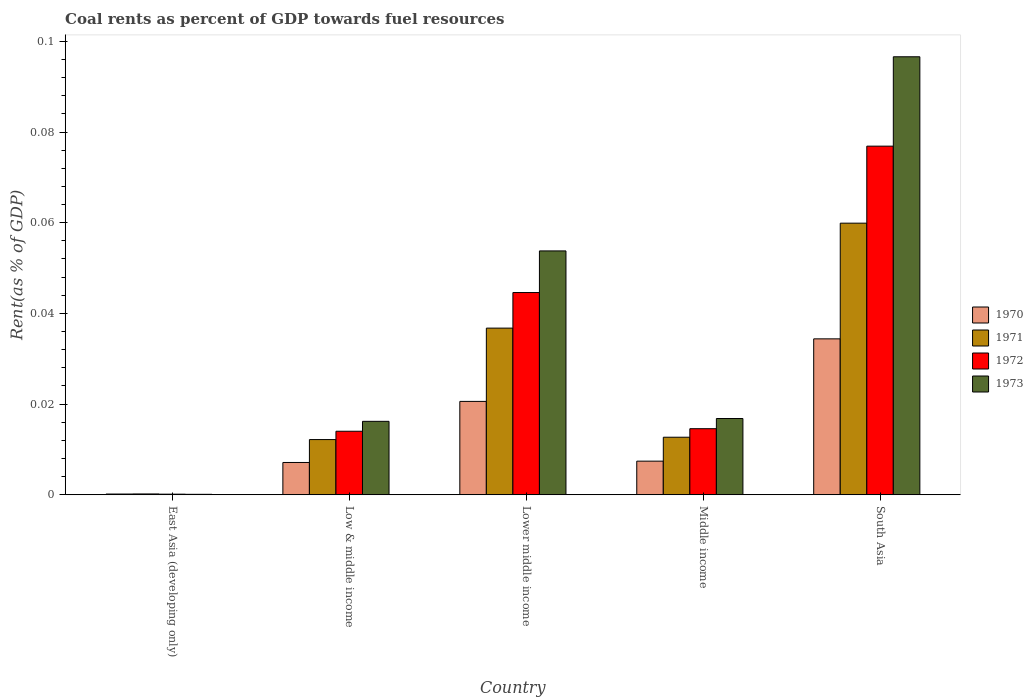Are the number of bars per tick equal to the number of legend labels?
Your answer should be very brief. Yes. How many bars are there on the 4th tick from the left?
Your answer should be compact. 4. How many bars are there on the 2nd tick from the right?
Your response must be concise. 4. What is the label of the 2nd group of bars from the left?
Your answer should be compact. Low & middle income. What is the coal rent in 1973 in East Asia (developing only)?
Your answer should be compact. 0. Across all countries, what is the maximum coal rent in 1970?
Keep it short and to the point. 0.03. Across all countries, what is the minimum coal rent in 1973?
Your answer should be compact. 0. In which country was the coal rent in 1973 maximum?
Offer a terse response. South Asia. In which country was the coal rent in 1971 minimum?
Keep it short and to the point. East Asia (developing only). What is the total coal rent in 1970 in the graph?
Your answer should be compact. 0.07. What is the difference between the coal rent in 1972 in Lower middle income and that in South Asia?
Provide a succinct answer. -0.03. What is the difference between the coal rent in 1972 in Low & middle income and the coal rent in 1971 in Middle income?
Provide a succinct answer. 0. What is the average coal rent in 1973 per country?
Give a very brief answer. 0.04. What is the difference between the coal rent of/in 1972 and coal rent of/in 1973 in South Asia?
Your response must be concise. -0.02. In how many countries, is the coal rent in 1970 greater than 0.04 %?
Provide a succinct answer. 0. What is the ratio of the coal rent in 1971 in East Asia (developing only) to that in Middle income?
Offer a terse response. 0.01. Is the coal rent in 1970 in East Asia (developing only) less than that in Lower middle income?
Your answer should be very brief. Yes. What is the difference between the highest and the second highest coal rent in 1973?
Make the answer very short. 0.08. What is the difference between the highest and the lowest coal rent in 1971?
Ensure brevity in your answer.  0.06. Is it the case that in every country, the sum of the coal rent in 1971 and coal rent in 1970 is greater than the sum of coal rent in 1973 and coal rent in 1972?
Your answer should be very brief. No. What does the 1st bar from the left in East Asia (developing only) represents?
Provide a succinct answer. 1970. Is it the case that in every country, the sum of the coal rent in 1973 and coal rent in 1970 is greater than the coal rent in 1971?
Your answer should be very brief. Yes. How many countries are there in the graph?
Offer a terse response. 5. Are the values on the major ticks of Y-axis written in scientific E-notation?
Provide a succinct answer. No. Does the graph contain any zero values?
Ensure brevity in your answer.  No. Does the graph contain grids?
Your response must be concise. No. Where does the legend appear in the graph?
Keep it short and to the point. Center right. What is the title of the graph?
Offer a terse response. Coal rents as percent of GDP towards fuel resources. What is the label or title of the X-axis?
Your answer should be very brief. Country. What is the label or title of the Y-axis?
Offer a terse response. Rent(as % of GDP). What is the Rent(as % of GDP) in 1970 in East Asia (developing only)?
Provide a succinct answer. 0. What is the Rent(as % of GDP) in 1971 in East Asia (developing only)?
Your answer should be compact. 0. What is the Rent(as % of GDP) in 1972 in East Asia (developing only)?
Make the answer very short. 0. What is the Rent(as % of GDP) in 1973 in East Asia (developing only)?
Keep it short and to the point. 0. What is the Rent(as % of GDP) of 1970 in Low & middle income?
Make the answer very short. 0.01. What is the Rent(as % of GDP) of 1971 in Low & middle income?
Your response must be concise. 0.01. What is the Rent(as % of GDP) in 1972 in Low & middle income?
Offer a terse response. 0.01. What is the Rent(as % of GDP) of 1973 in Low & middle income?
Provide a short and direct response. 0.02. What is the Rent(as % of GDP) in 1970 in Lower middle income?
Offer a terse response. 0.02. What is the Rent(as % of GDP) of 1971 in Lower middle income?
Your answer should be very brief. 0.04. What is the Rent(as % of GDP) in 1972 in Lower middle income?
Provide a succinct answer. 0.04. What is the Rent(as % of GDP) of 1973 in Lower middle income?
Keep it short and to the point. 0.05. What is the Rent(as % of GDP) in 1970 in Middle income?
Keep it short and to the point. 0.01. What is the Rent(as % of GDP) of 1971 in Middle income?
Provide a short and direct response. 0.01. What is the Rent(as % of GDP) in 1972 in Middle income?
Your answer should be compact. 0.01. What is the Rent(as % of GDP) in 1973 in Middle income?
Offer a terse response. 0.02. What is the Rent(as % of GDP) in 1970 in South Asia?
Give a very brief answer. 0.03. What is the Rent(as % of GDP) of 1971 in South Asia?
Provide a short and direct response. 0.06. What is the Rent(as % of GDP) in 1972 in South Asia?
Provide a succinct answer. 0.08. What is the Rent(as % of GDP) of 1973 in South Asia?
Make the answer very short. 0.1. Across all countries, what is the maximum Rent(as % of GDP) in 1970?
Offer a very short reply. 0.03. Across all countries, what is the maximum Rent(as % of GDP) of 1971?
Your answer should be compact. 0.06. Across all countries, what is the maximum Rent(as % of GDP) in 1972?
Your response must be concise. 0.08. Across all countries, what is the maximum Rent(as % of GDP) of 1973?
Provide a short and direct response. 0.1. Across all countries, what is the minimum Rent(as % of GDP) in 1970?
Offer a very short reply. 0. Across all countries, what is the minimum Rent(as % of GDP) of 1971?
Give a very brief answer. 0. Across all countries, what is the minimum Rent(as % of GDP) of 1972?
Provide a succinct answer. 0. Across all countries, what is the minimum Rent(as % of GDP) of 1973?
Your response must be concise. 0. What is the total Rent(as % of GDP) in 1970 in the graph?
Your answer should be compact. 0.07. What is the total Rent(as % of GDP) of 1971 in the graph?
Provide a succinct answer. 0.12. What is the total Rent(as % of GDP) in 1972 in the graph?
Provide a succinct answer. 0.15. What is the total Rent(as % of GDP) in 1973 in the graph?
Make the answer very short. 0.18. What is the difference between the Rent(as % of GDP) in 1970 in East Asia (developing only) and that in Low & middle income?
Give a very brief answer. -0.01. What is the difference between the Rent(as % of GDP) of 1971 in East Asia (developing only) and that in Low & middle income?
Provide a short and direct response. -0.01. What is the difference between the Rent(as % of GDP) in 1972 in East Asia (developing only) and that in Low & middle income?
Provide a succinct answer. -0.01. What is the difference between the Rent(as % of GDP) in 1973 in East Asia (developing only) and that in Low & middle income?
Offer a terse response. -0.02. What is the difference between the Rent(as % of GDP) of 1970 in East Asia (developing only) and that in Lower middle income?
Make the answer very short. -0.02. What is the difference between the Rent(as % of GDP) in 1971 in East Asia (developing only) and that in Lower middle income?
Keep it short and to the point. -0.04. What is the difference between the Rent(as % of GDP) in 1972 in East Asia (developing only) and that in Lower middle income?
Provide a succinct answer. -0.04. What is the difference between the Rent(as % of GDP) of 1973 in East Asia (developing only) and that in Lower middle income?
Your answer should be compact. -0.05. What is the difference between the Rent(as % of GDP) of 1970 in East Asia (developing only) and that in Middle income?
Provide a succinct answer. -0.01. What is the difference between the Rent(as % of GDP) of 1971 in East Asia (developing only) and that in Middle income?
Offer a terse response. -0.01. What is the difference between the Rent(as % of GDP) of 1972 in East Asia (developing only) and that in Middle income?
Provide a succinct answer. -0.01. What is the difference between the Rent(as % of GDP) of 1973 in East Asia (developing only) and that in Middle income?
Keep it short and to the point. -0.02. What is the difference between the Rent(as % of GDP) in 1970 in East Asia (developing only) and that in South Asia?
Your answer should be very brief. -0.03. What is the difference between the Rent(as % of GDP) of 1971 in East Asia (developing only) and that in South Asia?
Make the answer very short. -0.06. What is the difference between the Rent(as % of GDP) in 1972 in East Asia (developing only) and that in South Asia?
Your answer should be very brief. -0.08. What is the difference between the Rent(as % of GDP) in 1973 in East Asia (developing only) and that in South Asia?
Ensure brevity in your answer.  -0.1. What is the difference between the Rent(as % of GDP) in 1970 in Low & middle income and that in Lower middle income?
Offer a very short reply. -0.01. What is the difference between the Rent(as % of GDP) of 1971 in Low & middle income and that in Lower middle income?
Offer a terse response. -0.02. What is the difference between the Rent(as % of GDP) of 1972 in Low & middle income and that in Lower middle income?
Keep it short and to the point. -0.03. What is the difference between the Rent(as % of GDP) in 1973 in Low & middle income and that in Lower middle income?
Keep it short and to the point. -0.04. What is the difference between the Rent(as % of GDP) in 1970 in Low & middle income and that in Middle income?
Provide a succinct answer. -0. What is the difference between the Rent(as % of GDP) of 1971 in Low & middle income and that in Middle income?
Give a very brief answer. -0. What is the difference between the Rent(as % of GDP) in 1972 in Low & middle income and that in Middle income?
Keep it short and to the point. -0. What is the difference between the Rent(as % of GDP) in 1973 in Low & middle income and that in Middle income?
Your answer should be very brief. -0. What is the difference between the Rent(as % of GDP) of 1970 in Low & middle income and that in South Asia?
Keep it short and to the point. -0.03. What is the difference between the Rent(as % of GDP) in 1971 in Low & middle income and that in South Asia?
Provide a succinct answer. -0.05. What is the difference between the Rent(as % of GDP) in 1972 in Low & middle income and that in South Asia?
Make the answer very short. -0.06. What is the difference between the Rent(as % of GDP) of 1973 in Low & middle income and that in South Asia?
Provide a short and direct response. -0.08. What is the difference between the Rent(as % of GDP) in 1970 in Lower middle income and that in Middle income?
Keep it short and to the point. 0.01. What is the difference between the Rent(as % of GDP) in 1971 in Lower middle income and that in Middle income?
Provide a succinct answer. 0.02. What is the difference between the Rent(as % of GDP) of 1972 in Lower middle income and that in Middle income?
Keep it short and to the point. 0.03. What is the difference between the Rent(as % of GDP) of 1973 in Lower middle income and that in Middle income?
Your answer should be compact. 0.04. What is the difference between the Rent(as % of GDP) of 1970 in Lower middle income and that in South Asia?
Ensure brevity in your answer.  -0.01. What is the difference between the Rent(as % of GDP) of 1971 in Lower middle income and that in South Asia?
Your answer should be compact. -0.02. What is the difference between the Rent(as % of GDP) in 1972 in Lower middle income and that in South Asia?
Provide a succinct answer. -0.03. What is the difference between the Rent(as % of GDP) of 1973 in Lower middle income and that in South Asia?
Ensure brevity in your answer.  -0.04. What is the difference between the Rent(as % of GDP) of 1970 in Middle income and that in South Asia?
Your answer should be very brief. -0.03. What is the difference between the Rent(as % of GDP) of 1971 in Middle income and that in South Asia?
Ensure brevity in your answer.  -0.05. What is the difference between the Rent(as % of GDP) in 1972 in Middle income and that in South Asia?
Ensure brevity in your answer.  -0.06. What is the difference between the Rent(as % of GDP) in 1973 in Middle income and that in South Asia?
Your answer should be very brief. -0.08. What is the difference between the Rent(as % of GDP) in 1970 in East Asia (developing only) and the Rent(as % of GDP) in 1971 in Low & middle income?
Your answer should be compact. -0.01. What is the difference between the Rent(as % of GDP) in 1970 in East Asia (developing only) and the Rent(as % of GDP) in 1972 in Low & middle income?
Your answer should be very brief. -0.01. What is the difference between the Rent(as % of GDP) of 1970 in East Asia (developing only) and the Rent(as % of GDP) of 1973 in Low & middle income?
Your answer should be very brief. -0.02. What is the difference between the Rent(as % of GDP) in 1971 in East Asia (developing only) and the Rent(as % of GDP) in 1972 in Low & middle income?
Your answer should be compact. -0.01. What is the difference between the Rent(as % of GDP) in 1971 in East Asia (developing only) and the Rent(as % of GDP) in 1973 in Low & middle income?
Offer a very short reply. -0.02. What is the difference between the Rent(as % of GDP) in 1972 in East Asia (developing only) and the Rent(as % of GDP) in 1973 in Low & middle income?
Your answer should be very brief. -0.02. What is the difference between the Rent(as % of GDP) of 1970 in East Asia (developing only) and the Rent(as % of GDP) of 1971 in Lower middle income?
Your answer should be compact. -0.04. What is the difference between the Rent(as % of GDP) of 1970 in East Asia (developing only) and the Rent(as % of GDP) of 1972 in Lower middle income?
Your answer should be very brief. -0.04. What is the difference between the Rent(as % of GDP) of 1970 in East Asia (developing only) and the Rent(as % of GDP) of 1973 in Lower middle income?
Offer a terse response. -0.05. What is the difference between the Rent(as % of GDP) in 1971 in East Asia (developing only) and the Rent(as % of GDP) in 1972 in Lower middle income?
Provide a succinct answer. -0.04. What is the difference between the Rent(as % of GDP) in 1971 in East Asia (developing only) and the Rent(as % of GDP) in 1973 in Lower middle income?
Offer a very short reply. -0.05. What is the difference between the Rent(as % of GDP) in 1972 in East Asia (developing only) and the Rent(as % of GDP) in 1973 in Lower middle income?
Your answer should be compact. -0.05. What is the difference between the Rent(as % of GDP) in 1970 in East Asia (developing only) and the Rent(as % of GDP) in 1971 in Middle income?
Your answer should be very brief. -0.01. What is the difference between the Rent(as % of GDP) of 1970 in East Asia (developing only) and the Rent(as % of GDP) of 1972 in Middle income?
Offer a very short reply. -0.01. What is the difference between the Rent(as % of GDP) of 1970 in East Asia (developing only) and the Rent(as % of GDP) of 1973 in Middle income?
Your answer should be very brief. -0.02. What is the difference between the Rent(as % of GDP) in 1971 in East Asia (developing only) and the Rent(as % of GDP) in 1972 in Middle income?
Provide a succinct answer. -0.01. What is the difference between the Rent(as % of GDP) in 1971 in East Asia (developing only) and the Rent(as % of GDP) in 1973 in Middle income?
Give a very brief answer. -0.02. What is the difference between the Rent(as % of GDP) in 1972 in East Asia (developing only) and the Rent(as % of GDP) in 1973 in Middle income?
Provide a short and direct response. -0.02. What is the difference between the Rent(as % of GDP) of 1970 in East Asia (developing only) and the Rent(as % of GDP) of 1971 in South Asia?
Provide a short and direct response. -0.06. What is the difference between the Rent(as % of GDP) in 1970 in East Asia (developing only) and the Rent(as % of GDP) in 1972 in South Asia?
Ensure brevity in your answer.  -0.08. What is the difference between the Rent(as % of GDP) of 1970 in East Asia (developing only) and the Rent(as % of GDP) of 1973 in South Asia?
Give a very brief answer. -0.1. What is the difference between the Rent(as % of GDP) of 1971 in East Asia (developing only) and the Rent(as % of GDP) of 1972 in South Asia?
Your answer should be compact. -0.08. What is the difference between the Rent(as % of GDP) of 1971 in East Asia (developing only) and the Rent(as % of GDP) of 1973 in South Asia?
Offer a very short reply. -0.1. What is the difference between the Rent(as % of GDP) of 1972 in East Asia (developing only) and the Rent(as % of GDP) of 1973 in South Asia?
Your answer should be very brief. -0.1. What is the difference between the Rent(as % of GDP) in 1970 in Low & middle income and the Rent(as % of GDP) in 1971 in Lower middle income?
Make the answer very short. -0.03. What is the difference between the Rent(as % of GDP) in 1970 in Low & middle income and the Rent(as % of GDP) in 1972 in Lower middle income?
Provide a short and direct response. -0.04. What is the difference between the Rent(as % of GDP) of 1970 in Low & middle income and the Rent(as % of GDP) of 1973 in Lower middle income?
Provide a succinct answer. -0.05. What is the difference between the Rent(as % of GDP) of 1971 in Low & middle income and the Rent(as % of GDP) of 1972 in Lower middle income?
Give a very brief answer. -0.03. What is the difference between the Rent(as % of GDP) of 1971 in Low & middle income and the Rent(as % of GDP) of 1973 in Lower middle income?
Provide a short and direct response. -0.04. What is the difference between the Rent(as % of GDP) of 1972 in Low & middle income and the Rent(as % of GDP) of 1973 in Lower middle income?
Ensure brevity in your answer.  -0.04. What is the difference between the Rent(as % of GDP) in 1970 in Low & middle income and the Rent(as % of GDP) in 1971 in Middle income?
Keep it short and to the point. -0.01. What is the difference between the Rent(as % of GDP) of 1970 in Low & middle income and the Rent(as % of GDP) of 1972 in Middle income?
Ensure brevity in your answer.  -0.01. What is the difference between the Rent(as % of GDP) of 1970 in Low & middle income and the Rent(as % of GDP) of 1973 in Middle income?
Keep it short and to the point. -0.01. What is the difference between the Rent(as % of GDP) of 1971 in Low & middle income and the Rent(as % of GDP) of 1972 in Middle income?
Provide a short and direct response. -0. What is the difference between the Rent(as % of GDP) of 1971 in Low & middle income and the Rent(as % of GDP) of 1973 in Middle income?
Provide a succinct answer. -0. What is the difference between the Rent(as % of GDP) in 1972 in Low & middle income and the Rent(as % of GDP) in 1973 in Middle income?
Make the answer very short. -0. What is the difference between the Rent(as % of GDP) in 1970 in Low & middle income and the Rent(as % of GDP) in 1971 in South Asia?
Offer a very short reply. -0.05. What is the difference between the Rent(as % of GDP) of 1970 in Low & middle income and the Rent(as % of GDP) of 1972 in South Asia?
Your response must be concise. -0.07. What is the difference between the Rent(as % of GDP) of 1970 in Low & middle income and the Rent(as % of GDP) of 1973 in South Asia?
Your answer should be compact. -0.09. What is the difference between the Rent(as % of GDP) in 1971 in Low & middle income and the Rent(as % of GDP) in 1972 in South Asia?
Your answer should be very brief. -0.06. What is the difference between the Rent(as % of GDP) in 1971 in Low & middle income and the Rent(as % of GDP) in 1973 in South Asia?
Keep it short and to the point. -0.08. What is the difference between the Rent(as % of GDP) in 1972 in Low & middle income and the Rent(as % of GDP) in 1973 in South Asia?
Your answer should be compact. -0.08. What is the difference between the Rent(as % of GDP) of 1970 in Lower middle income and the Rent(as % of GDP) of 1971 in Middle income?
Your response must be concise. 0.01. What is the difference between the Rent(as % of GDP) in 1970 in Lower middle income and the Rent(as % of GDP) in 1972 in Middle income?
Offer a very short reply. 0.01. What is the difference between the Rent(as % of GDP) of 1970 in Lower middle income and the Rent(as % of GDP) of 1973 in Middle income?
Provide a short and direct response. 0. What is the difference between the Rent(as % of GDP) of 1971 in Lower middle income and the Rent(as % of GDP) of 1972 in Middle income?
Keep it short and to the point. 0.02. What is the difference between the Rent(as % of GDP) in 1971 in Lower middle income and the Rent(as % of GDP) in 1973 in Middle income?
Give a very brief answer. 0.02. What is the difference between the Rent(as % of GDP) of 1972 in Lower middle income and the Rent(as % of GDP) of 1973 in Middle income?
Your answer should be very brief. 0.03. What is the difference between the Rent(as % of GDP) in 1970 in Lower middle income and the Rent(as % of GDP) in 1971 in South Asia?
Offer a very short reply. -0.04. What is the difference between the Rent(as % of GDP) of 1970 in Lower middle income and the Rent(as % of GDP) of 1972 in South Asia?
Your answer should be compact. -0.06. What is the difference between the Rent(as % of GDP) of 1970 in Lower middle income and the Rent(as % of GDP) of 1973 in South Asia?
Ensure brevity in your answer.  -0.08. What is the difference between the Rent(as % of GDP) in 1971 in Lower middle income and the Rent(as % of GDP) in 1972 in South Asia?
Give a very brief answer. -0.04. What is the difference between the Rent(as % of GDP) in 1971 in Lower middle income and the Rent(as % of GDP) in 1973 in South Asia?
Your answer should be compact. -0.06. What is the difference between the Rent(as % of GDP) of 1972 in Lower middle income and the Rent(as % of GDP) of 1973 in South Asia?
Ensure brevity in your answer.  -0.05. What is the difference between the Rent(as % of GDP) in 1970 in Middle income and the Rent(as % of GDP) in 1971 in South Asia?
Provide a short and direct response. -0.05. What is the difference between the Rent(as % of GDP) in 1970 in Middle income and the Rent(as % of GDP) in 1972 in South Asia?
Give a very brief answer. -0.07. What is the difference between the Rent(as % of GDP) in 1970 in Middle income and the Rent(as % of GDP) in 1973 in South Asia?
Make the answer very short. -0.09. What is the difference between the Rent(as % of GDP) of 1971 in Middle income and the Rent(as % of GDP) of 1972 in South Asia?
Ensure brevity in your answer.  -0.06. What is the difference between the Rent(as % of GDP) in 1971 in Middle income and the Rent(as % of GDP) in 1973 in South Asia?
Provide a short and direct response. -0.08. What is the difference between the Rent(as % of GDP) of 1972 in Middle income and the Rent(as % of GDP) of 1973 in South Asia?
Ensure brevity in your answer.  -0.08. What is the average Rent(as % of GDP) in 1970 per country?
Your response must be concise. 0.01. What is the average Rent(as % of GDP) of 1971 per country?
Give a very brief answer. 0.02. What is the average Rent(as % of GDP) of 1972 per country?
Ensure brevity in your answer.  0.03. What is the average Rent(as % of GDP) in 1973 per country?
Provide a short and direct response. 0.04. What is the difference between the Rent(as % of GDP) of 1970 and Rent(as % of GDP) of 1971 in East Asia (developing only)?
Your answer should be very brief. -0. What is the difference between the Rent(as % of GDP) in 1970 and Rent(as % of GDP) in 1973 in East Asia (developing only)?
Provide a short and direct response. 0. What is the difference between the Rent(as % of GDP) of 1971 and Rent(as % of GDP) of 1972 in East Asia (developing only)?
Provide a short and direct response. 0. What is the difference between the Rent(as % of GDP) in 1972 and Rent(as % of GDP) in 1973 in East Asia (developing only)?
Offer a terse response. 0. What is the difference between the Rent(as % of GDP) of 1970 and Rent(as % of GDP) of 1971 in Low & middle income?
Ensure brevity in your answer.  -0.01. What is the difference between the Rent(as % of GDP) in 1970 and Rent(as % of GDP) in 1972 in Low & middle income?
Offer a very short reply. -0.01. What is the difference between the Rent(as % of GDP) in 1970 and Rent(as % of GDP) in 1973 in Low & middle income?
Ensure brevity in your answer.  -0.01. What is the difference between the Rent(as % of GDP) in 1971 and Rent(as % of GDP) in 1972 in Low & middle income?
Ensure brevity in your answer.  -0. What is the difference between the Rent(as % of GDP) of 1971 and Rent(as % of GDP) of 1973 in Low & middle income?
Your response must be concise. -0. What is the difference between the Rent(as % of GDP) in 1972 and Rent(as % of GDP) in 1973 in Low & middle income?
Provide a succinct answer. -0. What is the difference between the Rent(as % of GDP) of 1970 and Rent(as % of GDP) of 1971 in Lower middle income?
Make the answer very short. -0.02. What is the difference between the Rent(as % of GDP) of 1970 and Rent(as % of GDP) of 1972 in Lower middle income?
Your answer should be very brief. -0.02. What is the difference between the Rent(as % of GDP) of 1970 and Rent(as % of GDP) of 1973 in Lower middle income?
Ensure brevity in your answer.  -0.03. What is the difference between the Rent(as % of GDP) of 1971 and Rent(as % of GDP) of 1972 in Lower middle income?
Provide a short and direct response. -0.01. What is the difference between the Rent(as % of GDP) of 1971 and Rent(as % of GDP) of 1973 in Lower middle income?
Give a very brief answer. -0.02. What is the difference between the Rent(as % of GDP) in 1972 and Rent(as % of GDP) in 1973 in Lower middle income?
Give a very brief answer. -0.01. What is the difference between the Rent(as % of GDP) in 1970 and Rent(as % of GDP) in 1971 in Middle income?
Offer a terse response. -0.01. What is the difference between the Rent(as % of GDP) in 1970 and Rent(as % of GDP) in 1972 in Middle income?
Keep it short and to the point. -0.01. What is the difference between the Rent(as % of GDP) in 1970 and Rent(as % of GDP) in 1973 in Middle income?
Give a very brief answer. -0.01. What is the difference between the Rent(as % of GDP) in 1971 and Rent(as % of GDP) in 1972 in Middle income?
Provide a succinct answer. -0. What is the difference between the Rent(as % of GDP) of 1971 and Rent(as % of GDP) of 1973 in Middle income?
Keep it short and to the point. -0. What is the difference between the Rent(as % of GDP) of 1972 and Rent(as % of GDP) of 1973 in Middle income?
Make the answer very short. -0. What is the difference between the Rent(as % of GDP) in 1970 and Rent(as % of GDP) in 1971 in South Asia?
Provide a succinct answer. -0.03. What is the difference between the Rent(as % of GDP) in 1970 and Rent(as % of GDP) in 1972 in South Asia?
Provide a succinct answer. -0.04. What is the difference between the Rent(as % of GDP) of 1970 and Rent(as % of GDP) of 1973 in South Asia?
Offer a very short reply. -0.06. What is the difference between the Rent(as % of GDP) of 1971 and Rent(as % of GDP) of 1972 in South Asia?
Your answer should be compact. -0.02. What is the difference between the Rent(as % of GDP) in 1971 and Rent(as % of GDP) in 1973 in South Asia?
Provide a short and direct response. -0.04. What is the difference between the Rent(as % of GDP) in 1972 and Rent(as % of GDP) in 1973 in South Asia?
Provide a succinct answer. -0.02. What is the ratio of the Rent(as % of GDP) in 1970 in East Asia (developing only) to that in Low & middle income?
Make the answer very short. 0.02. What is the ratio of the Rent(as % of GDP) of 1971 in East Asia (developing only) to that in Low & middle income?
Your response must be concise. 0.02. What is the ratio of the Rent(as % of GDP) in 1972 in East Asia (developing only) to that in Low & middle income?
Your response must be concise. 0.01. What is the ratio of the Rent(as % of GDP) of 1973 in East Asia (developing only) to that in Low & middle income?
Keep it short and to the point. 0.01. What is the ratio of the Rent(as % of GDP) of 1970 in East Asia (developing only) to that in Lower middle income?
Your response must be concise. 0.01. What is the ratio of the Rent(as % of GDP) of 1971 in East Asia (developing only) to that in Lower middle income?
Make the answer very short. 0.01. What is the ratio of the Rent(as % of GDP) of 1972 in East Asia (developing only) to that in Lower middle income?
Provide a succinct answer. 0. What is the ratio of the Rent(as % of GDP) of 1973 in East Asia (developing only) to that in Lower middle income?
Give a very brief answer. 0. What is the ratio of the Rent(as % of GDP) of 1970 in East Asia (developing only) to that in Middle income?
Offer a terse response. 0.02. What is the ratio of the Rent(as % of GDP) in 1971 in East Asia (developing only) to that in Middle income?
Your response must be concise. 0.01. What is the ratio of the Rent(as % of GDP) of 1972 in East Asia (developing only) to that in Middle income?
Your answer should be compact. 0.01. What is the ratio of the Rent(as % of GDP) in 1973 in East Asia (developing only) to that in Middle income?
Make the answer very short. 0.01. What is the ratio of the Rent(as % of GDP) of 1970 in East Asia (developing only) to that in South Asia?
Make the answer very short. 0. What is the ratio of the Rent(as % of GDP) in 1971 in East Asia (developing only) to that in South Asia?
Keep it short and to the point. 0. What is the ratio of the Rent(as % of GDP) in 1972 in East Asia (developing only) to that in South Asia?
Ensure brevity in your answer.  0. What is the ratio of the Rent(as % of GDP) of 1973 in East Asia (developing only) to that in South Asia?
Make the answer very short. 0. What is the ratio of the Rent(as % of GDP) of 1970 in Low & middle income to that in Lower middle income?
Provide a short and direct response. 0.35. What is the ratio of the Rent(as % of GDP) in 1971 in Low & middle income to that in Lower middle income?
Your response must be concise. 0.33. What is the ratio of the Rent(as % of GDP) of 1972 in Low & middle income to that in Lower middle income?
Give a very brief answer. 0.31. What is the ratio of the Rent(as % of GDP) of 1973 in Low & middle income to that in Lower middle income?
Provide a succinct answer. 0.3. What is the ratio of the Rent(as % of GDP) of 1970 in Low & middle income to that in Middle income?
Ensure brevity in your answer.  0.96. What is the ratio of the Rent(as % of GDP) of 1971 in Low & middle income to that in Middle income?
Your response must be concise. 0.96. What is the ratio of the Rent(as % of GDP) of 1972 in Low & middle income to that in Middle income?
Your response must be concise. 0.96. What is the ratio of the Rent(as % of GDP) in 1973 in Low & middle income to that in Middle income?
Give a very brief answer. 0.96. What is the ratio of the Rent(as % of GDP) in 1970 in Low & middle income to that in South Asia?
Ensure brevity in your answer.  0.21. What is the ratio of the Rent(as % of GDP) in 1971 in Low & middle income to that in South Asia?
Provide a succinct answer. 0.2. What is the ratio of the Rent(as % of GDP) of 1972 in Low & middle income to that in South Asia?
Your answer should be compact. 0.18. What is the ratio of the Rent(as % of GDP) in 1973 in Low & middle income to that in South Asia?
Your response must be concise. 0.17. What is the ratio of the Rent(as % of GDP) of 1970 in Lower middle income to that in Middle income?
Your response must be concise. 2.78. What is the ratio of the Rent(as % of GDP) of 1971 in Lower middle income to that in Middle income?
Your response must be concise. 2.9. What is the ratio of the Rent(as % of GDP) in 1972 in Lower middle income to that in Middle income?
Make the answer very short. 3.06. What is the ratio of the Rent(as % of GDP) of 1973 in Lower middle income to that in Middle income?
Your response must be concise. 3.2. What is the ratio of the Rent(as % of GDP) in 1970 in Lower middle income to that in South Asia?
Provide a short and direct response. 0.6. What is the ratio of the Rent(as % of GDP) of 1971 in Lower middle income to that in South Asia?
Offer a very short reply. 0.61. What is the ratio of the Rent(as % of GDP) of 1972 in Lower middle income to that in South Asia?
Offer a terse response. 0.58. What is the ratio of the Rent(as % of GDP) in 1973 in Lower middle income to that in South Asia?
Your answer should be very brief. 0.56. What is the ratio of the Rent(as % of GDP) in 1970 in Middle income to that in South Asia?
Your response must be concise. 0.22. What is the ratio of the Rent(as % of GDP) of 1971 in Middle income to that in South Asia?
Keep it short and to the point. 0.21. What is the ratio of the Rent(as % of GDP) in 1972 in Middle income to that in South Asia?
Your answer should be compact. 0.19. What is the ratio of the Rent(as % of GDP) of 1973 in Middle income to that in South Asia?
Offer a terse response. 0.17. What is the difference between the highest and the second highest Rent(as % of GDP) in 1970?
Offer a very short reply. 0.01. What is the difference between the highest and the second highest Rent(as % of GDP) in 1971?
Offer a terse response. 0.02. What is the difference between the highest and the second highest Rent(as % of GDP) of 1972?
Provide a short and direct response. 0.03. What is the difference between the highest and the second highest Rent(as % of GDP) in 1973?
Provide a succinct answer. 0.04. What is the difference between the highest and the lowest Rent(as % of GDP) in 1970?
Your response must be concise. 0.03. What is the difference between the highest and the lowest Rent(as % of GDP) in 1971?
Your answer should be compact. 0.06. What is the difference between the highest and the lowest Rent(as % of GDP) in 1972?
Your answer should be compact. 0.08. What is the difference between the highest and the lowest Rent(as % of GDP) in 1973?
Your response must be concise. 0.1. 